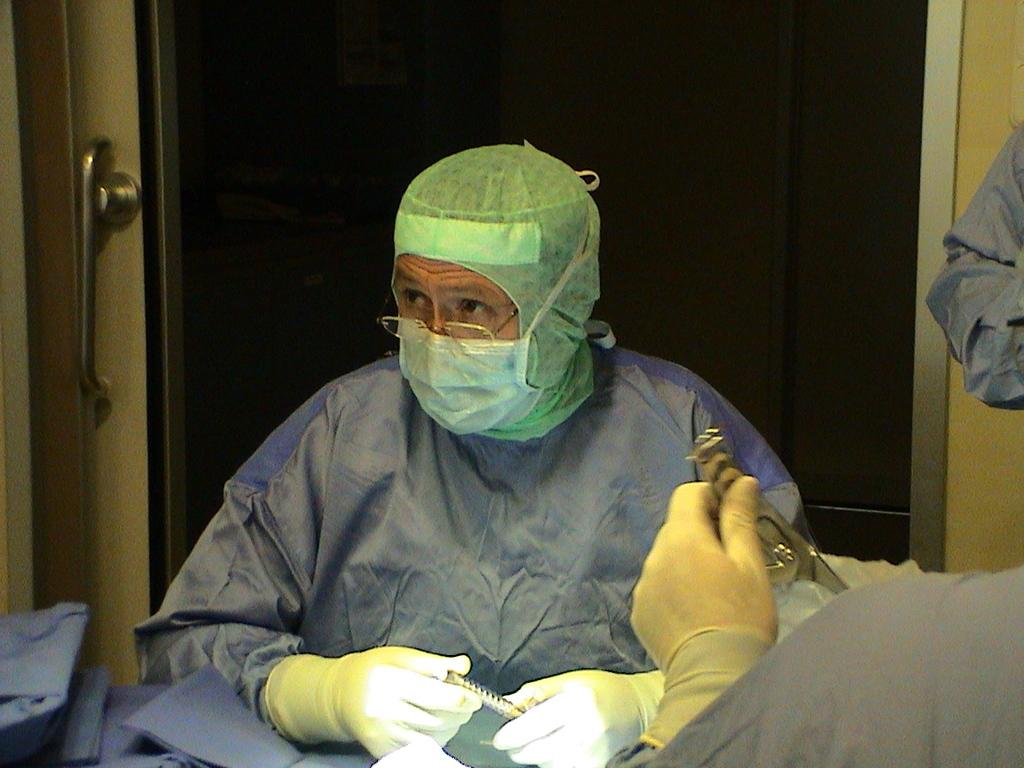How many people are in the image? There are two persons in the image. What are the persons wearing on their hands? The persons are wearing gloves. Can you describe any accessories worn by one of the persons? One of the persons is wearing spectacles. What can be seen in the background of the image? There is a door visible in the background of the image. What type of toe is visible on the monkey in the image? There is no monkey present in the image, so it is not possible to determine what type of toe might be visible. 